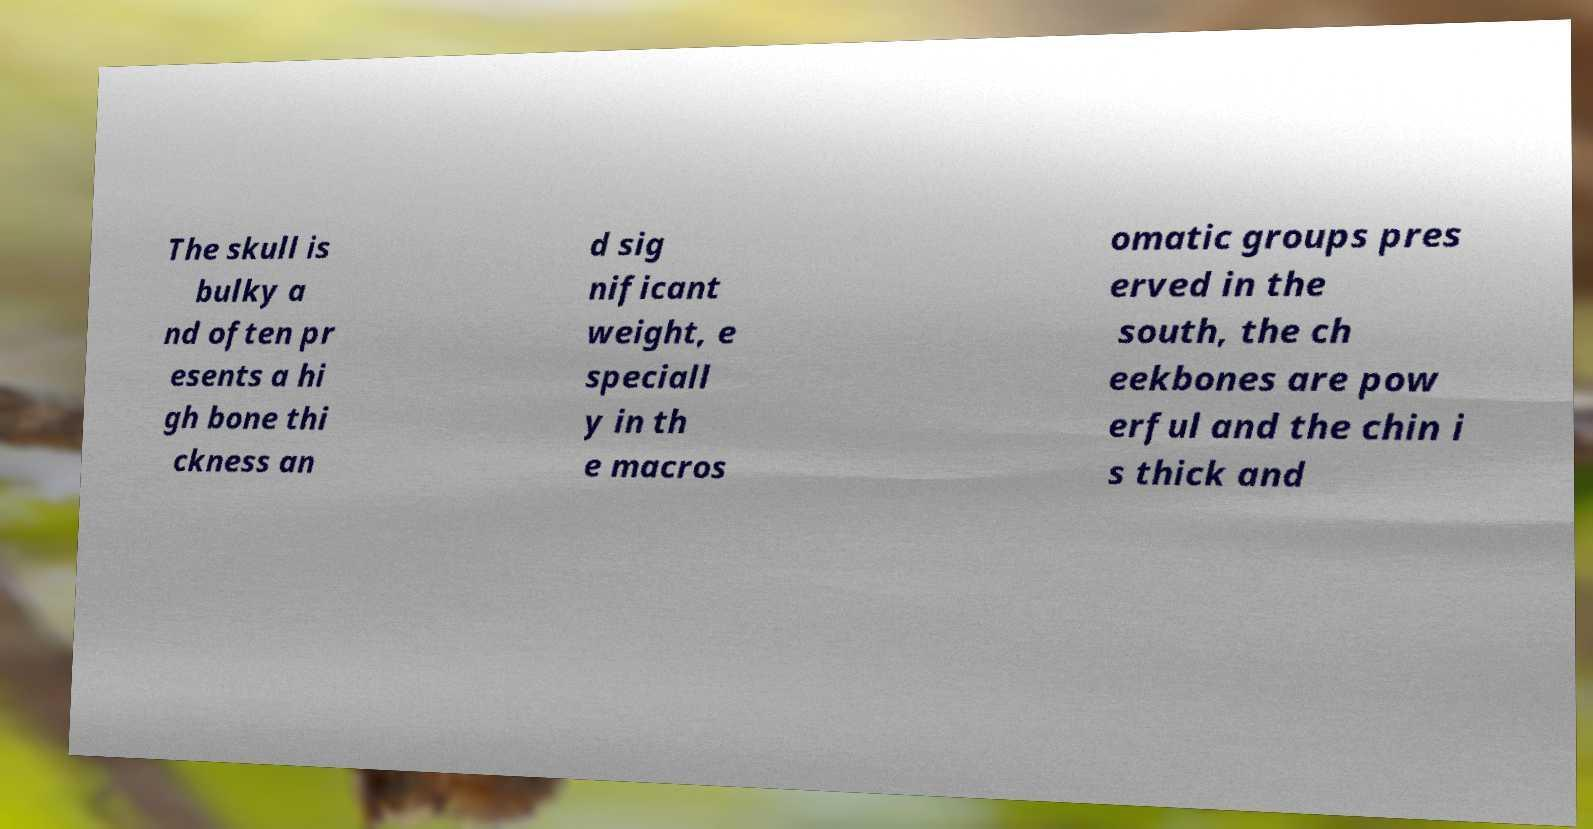Can you read and provide the text displayed in the image?This photo seems to have some interesting text. Can you extract and type it out for me? The skull is bulky a nd often pr esents a hi gh bone thi ckness an d sig nificant weight, e speciall y in th e macros omatic groups pres erved in the south, the ch eekbones are pow erful and the chin i s thick and 